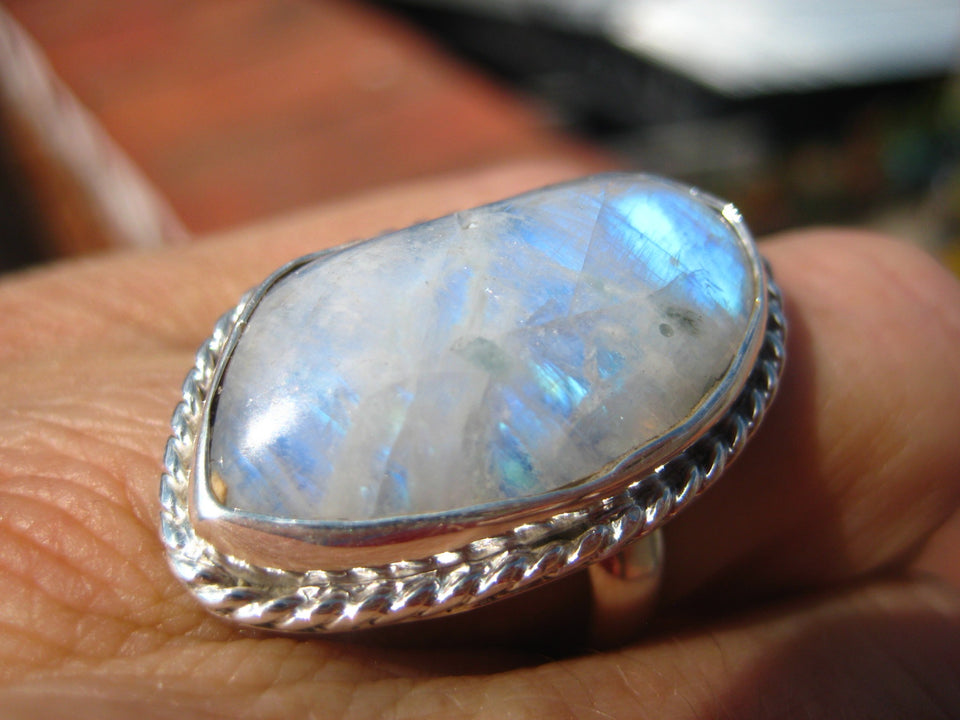What can you tell me about the craftsmanship of this opal ring? The craftsmanship of this opal ring is quite exquisite. The opal is carefully set in a polished silver band, which enhances the stone's natural beauty. The silver setting has a braided texture, adding a refined elegance to the design. This type of setting not only secures the gemstone but also complements its play-of-color, making the overall piece very attractive. How does the size of this opal compare to typical stones used in jewelry? The opal in this ring appears to be quite large compared to typical stones used in jewelry. Larger opals like this are relatively rare and tend to be more valuable, especially when they exhibit a strong and vibrant play-of-color. The size also allows for a more impactful display of the gemstone's characteristic color patterns, making it a centerpiece in any collection. If this opal ring could tell a story, what do you think it would say? If this opal ring could tell a story, it might recount tales from the ancient seas where it formed, whispering secrets of the Earth's early days. It would speak of the eons spent buried within rock, waiting patiently to be discovered and brought to light. Each flash of color could reveal a moment in time, a glimpse of the eternal dance of nature. It would share the journey from raw stone to a polished gem, the hands of the artisan that crafted it into a piece of wearable art, and the wonder it inspires every time it catches the light. This ring embodies the timeless beauty of the natural world, captured and preserved in a single moment of splendor. 